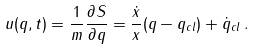Convert formula to latex. <formula><loc_0><loc_0><loc_500><loc_500>u ( q , t ) = \frac { 1 } { m } \frac { \partial S } { \partial q } = \frac { \dot { x } } { x } ( q - q _ { c l } ) + \dot { q } _ { c l } \, .</formula> 